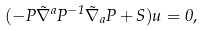Convert formula to latex. <formula><loc_0><loc_0><loc_500><loc_500>( - P \tilde { \nabla } ^ { a } P ^ { - 1 } \tilde { \nabla } _ { a } P + S ) u = 0 ,</formula> 